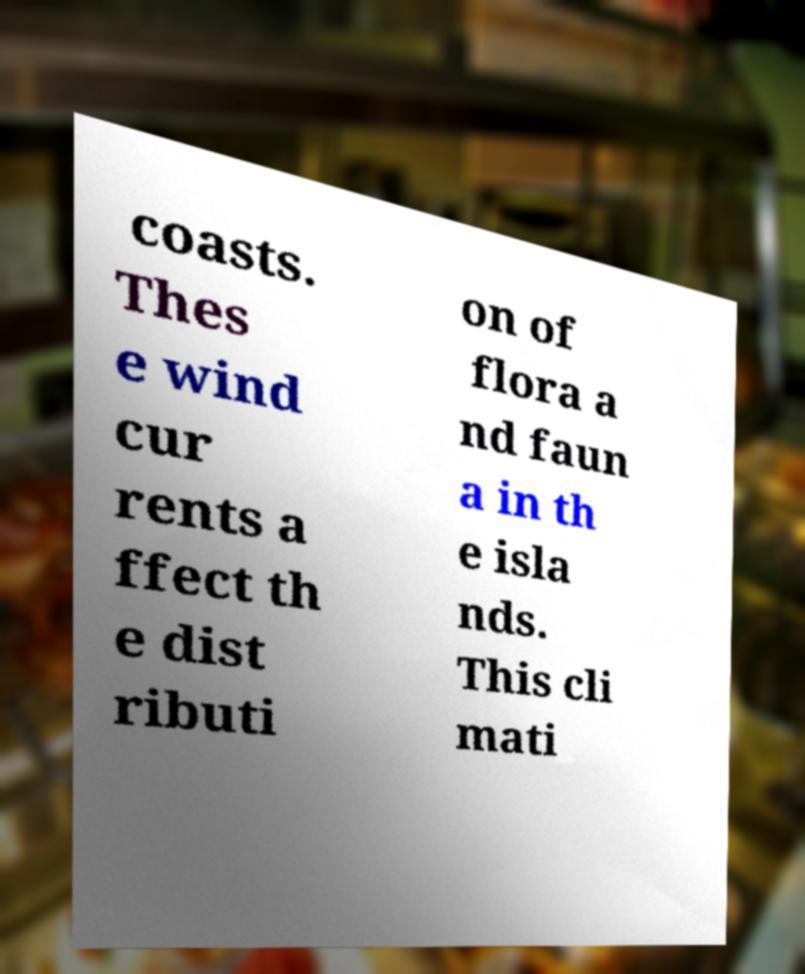Could you assist in decoding the text presented in this image and type it out clearly? coasts. Thes e wind cur rents a ffect th e dist ributi on of flora a nd faun a in th e isla nds. This cli mati 